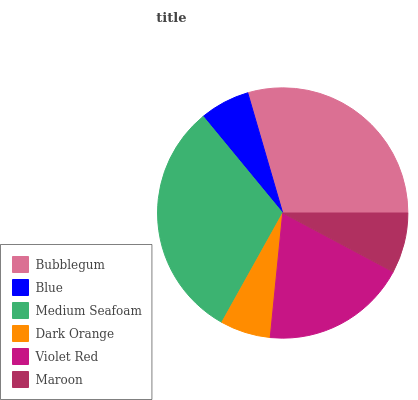Is Blue the minimum?
Answer yes or no. Yes. Is Medium Seafoam the maximum?
Answer yes or no. Yes. Is Medium Seafoam the minimum?
Answer yes or no. No. Is Blue the maximum?
Answer yes or no. No. Is Medium Seafoam greater than Blue?
Answer yes or no. Yes. Is Blue less than Medium Seafoam?
Answer yes or no. Yes. Is Blue greater than Medium Seafoam?
Answer yes or no. No. Is Medium Seafoam less than Blue?
Answer yes or no. No. Is Violet Red the high median?
Answer yes or no. Yes. Is Maroon the low median?
Answer yes or no. Yes. Is Blue the high median?
Answer yes or no. No. Is Blue the low median?
Answer yes or no. No. 